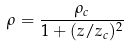<formula> <loc_0><loc_0><loc_500><loc_500>\rho = \frac { \rho _ { c } } { 1 + ( z / z _ { c } ) ^ { 2 } }</formula> 